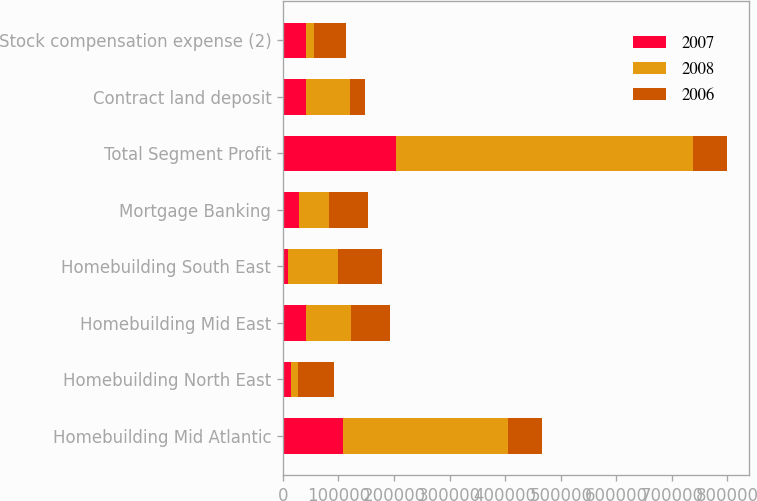Convert chart. <chart><loc_0><loc_0><loc_500><loc_500><stacked_bar_chart><ecel><fcel>Homebuilding Mid Atlantic<fcel>Homebuilding North East<fcel>Homebuilding Mid East<fcel>Homebuilding South East<fcel>Mortgage Banking<fcel>Total Segment Profit<fcel>Contract land deposit<fcel>Stock compensation expense (2)<nl><fcel>2007<fcel>108561<fcel>14761<fcel>42296<fcel>9286<fcel>29227<fcel>204131<fcel>41134<fcel>41204<nl><fcel>2008<fcel>296049<fcel>12618<fcel>80969<fcel>89785<fcel>54576<fcel>533997<fcel>79002<fcel>14189<nl><fcel>2006<fcel>61190<fcel>64246<fcel>69911<fcel>79948<fcel>68753<fcel>61190<fcel>27717<fcel>58134<nl></chart> 